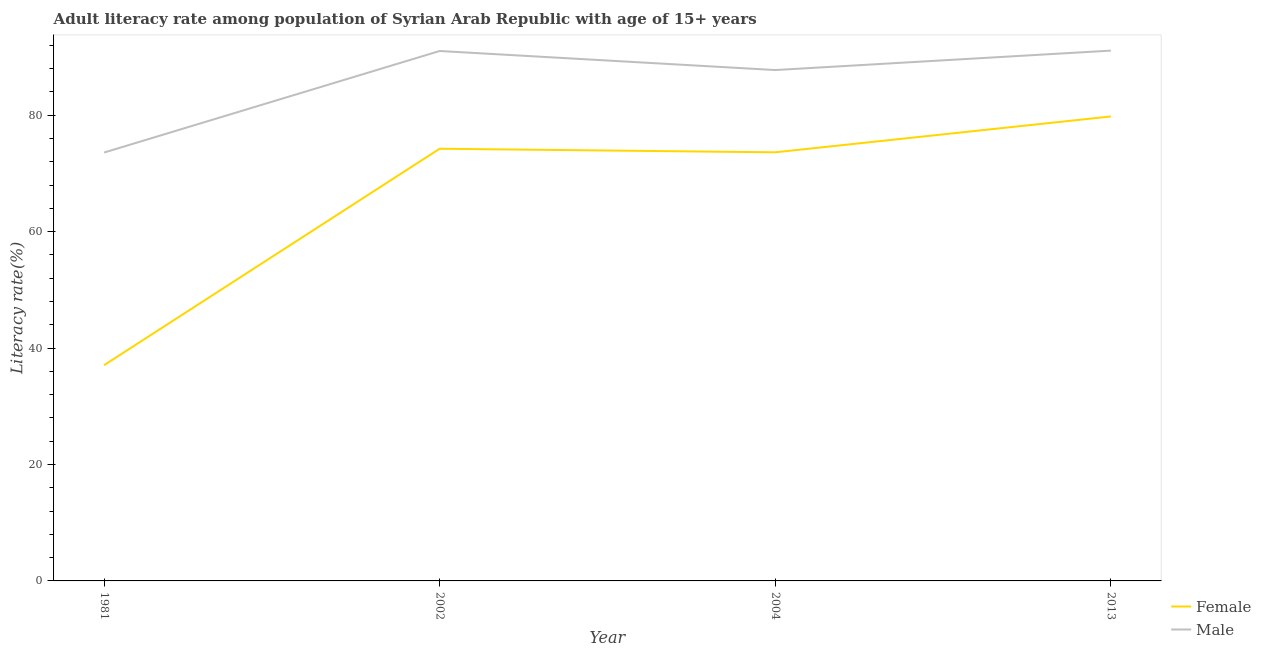Is the number of lines equal to the number of legend labels?
Keep it short and to the point. Yes. What is the male adult literacy rate in 2002?
Keep it short and to the point. 91.03. Across all years, what is the maximum female adult literacy rate?
Give a very brief answer. 79.79. Across all years, what is the minimum male adult literacy rate?
Provide a short and direct response. 73.58. What is the total female adult literacy rate in the graph?
Ensure brevity in your answer.  264.71. What is the difference between the female adult literacy rate in 2004 and that in 2013?
Make the answer very short. -6.16. What is the difference between the female adult literacy rate in 2004 and the male adult literacy rate in 2002?
Offer a terse response. -17.4. What is the average male adult literacy rate per year?
Provide a succinct answer. 85.87. In the year 2002, what is the difference between the male adult literacy rate and female adult literacy rate?
Offer a terse response. 16.79. What is the ratio of the male adult literacy rate in 2004 to that in 2013?
Ensure brevity in your answer.  0.96. Is the female adult literacy rate in 2002 less than that in 2013?
Keep it short and to the point. Yes. What is the difference between the highest and the second highest male adult literacy rate?
Keep it short and to the point. 0.07. What is the difference between the highest and the lowest female adult literacy rate?
Make the answer very short. 42.73. Is the female adult literacy rate strictly less than the male adult literacy rate over the years?
Give a very brief answer. Yes. How many years are there in the graph?
Your answer should be compact. 4. Are the values on the major ticks of Y-axis written in scientific E-notation?
Ensure brevity in your answer.  No. Does the graph contain any zero values?
Make the answer very short. No. Where does the legend appear in the graph?
Make the answer very short. Bottom right. How many legend labels are there?
Your response must be concise. 2. How are the legend labels stacked?
Offer a terse response. Vertical. What is the title of the graph?
Make the answer very short. Adult literacy rate among population of Syrian Arab Republic with age of 15+ years. What is the label or title of the Y-axis?
Make the answer very short. Literacy rate(%). What is the Literacy rate(%) in Female in 1981?
Your answer should be compact. 37.06. What is the Literacy rate(%) of Male in 1981?
Keep it short and to the point. 73.58. What is the Literacy rate(%) in Female in 2002?
Ensure brevity in your answer.  74.24. What is the Literacy rate(%) in Male in 2002?
Ensure brevity in your answer.  91.03. What is the Literacy rate(%) in Female in 2004?
Your answer should be compact. 73.63. What is the Literacy rate(%) of Male in 2004?
Offer a terse response. 87.76. What is the Literacy rate(%) in Female in 2013?
Keep it short and to the point. 79.79. What is the Literacy rate(%) in Male in 2013?
Offer a very short reply. 91.1. Across all years, what is the maximum Literacy rate(%) of Female?
Your answer should be compact. 79.79. Across all years, what is the maximum Literacy rate(%) of Male?
Your answer should be compact. 91.1. Across all years, what is the minimum Literacy rate(%) of Female?
Your answer should be very brief. 37.06. Across all years, what is the minimum Literacy rate(%) in Male?
Your response must be concise. 73.58. What is the total Literacy rate(%) of Female in the graph?
Keep it short and to the point. 264.71. What is the total Literacy rate(%) in Male in the graph?
Ensure brevity in your answer.  343.47. What is the difference between the Literacy rate(%) in Female in 1981 and that in 2002?
Your response must be concise. -37.18. What is the difference between the Literacy rate(%) in Male in 1981 and that in 2002?
Make the answer very short. -17.44. What is the difference between the Literacy rate(%) of Female in 1981 and that in 2004?
Your answer should be very brief. -36.57. What is the difference between the Literacy rate(%) in Male in 1981 and that in 2004?
Offer a very short reply. -14.17. What is the difference between the Literacy rate(%) of Female in 1981 and that in 2013?
Your answer should be very brief. -42.73. What is the difference between the Literacy rate(%) of Male in 1981 and that in 2013?
Offer a terse response. -17.51. What is the difference between the Literacy rate(%) in Female in 2002 and that in 2004?
Provide a succinct answer. 0.61. What is the difference between the Literacy rate(%) in Male in 2002 and that in 2004?
Offer a terse response. 3.27. What is the difference between the Literacy rate(%) of Female in 2002 and that in 2013?
Provide a succinct answer. -5.55. What is the difference between the Literacy rate(%) of Male in 2002 and that in 2013?
Provide a succinct answer. -0.07. What is the difference between the Literacy rate(%) in Female in 2004 and that in 2013?
Ensure brevity in your answer.  -6.16. What is the difference between the Literacy rate(%) in Male in 2004 and that in 2013?
Keep it short and to the point. -3.34. What is the difference between the Literacy rate(%) of Female in 1981 and the Literacy rate(%) of Male in 2002?
Ensure brevity in your answer.  -53.97. What is the difference between the Literacy rate(%) in Female in 1981 and the Literacy rate(%) in Male in 2004?
Give a very brief answer. -50.7. What is the difference between the Literacy rate(%) in Female in 1981 and the Literacy rate(%) in Male in 2013?
Make the answer very short. -54.04. What is the difference between the Literacy rate(%) in Female in 2002 and the Literacy rate(%) in Male in 2004?
Keep it short and to the point. -13.52. What is the difference between the Literacy rate(%) in Female in 2002 and the Literacy rate(%) in Male in 2013?
Your answer should be very brief. -16.86. What is the difference between the Literacy rate(%) in Female in 2004 and the Literacy rate(%) in Male in 2013?
Make the answer very short. -17.47. What is the average Literacy rate(%) in Female per year?
Give a very brief answer. 66.18. What is the average Literacy rate(%) in Male per year?
Your answer should be very brief. 85.87. In the year 1981, what is the difference between the Literacy rate(%) in Female and Literacy rate(%) in Male?
Give a very brief answer. -36.53. In the year 2002, what is the difference between the Literacy rate(%) in Female and Literacy rate(%) in Male?
Ensure brevity in your answer.  -16.79. In the year 2004, what is the difference between the Literacy rate(%) in Female and Literacy rate(%) in Male?
Your answer should be very brief. -14.13. In the year 2013, what is the difference between the Literacy rate(%) of Female and Literacy rate(%) of Male?
Provide a short and direct response. -11.31. What is the ratio of the Literacy rate(%) of Female in 1981 to that in 2002?
Give a very brief answer. 0.5. What is the ratio of the Literacy rate(%) in Male in 1981 to that in 2002?
Your answer should be very brief. 0.81. What is the ratio of the Literacy rate(%) in Female in 1981 to that in 2004?
Offer a very short reply. 0.5. What is the ratio of the Literacy rate(%) in Male in 1981 to that in 2004?
Your answer should be compact. 0.84. What is the ratio of the Literacy rate(%) of Female in 1981 to that in 2013?
Your answer should be compact. 0.46. What is the ratio of the Literacy rate(%) of Male in 1981 to that in 2013?
Offer a very short reply. 0.81. What is the ratio of the Literacy rate(%) in Female in 2002 to that in 2004?
Keep it short and to the point. 1.01. What is the ratio of the Literacy rate(%) of Male in 2002 to that in 2004?
Make the answer very short. 1.04. What is the ratio of the Literacy rate(%) in Female in 2002 to that in 2013?
Offer a very short reply. 0.93. What is the ratio of the Literacy rate(%) of Female in 2004 to that in 2013?
Your answer should be very brief. 0.92. What is the ratio of the Literacy rate(%) in Male in 2004 to that in 2013?
Offer a terse response. 0.96. What is the difference between the highest and the second highest Literacy rate(%) in Female?
Offer a very short reply. 5.55. What is the difference between the highest and the second highest Literacy rate(%) in Male?
Your answer should be compact. 0.07. What is the difference between the highest and the lowest Literacy rate(%) of Female?
Your answer should be very brief. 42.73. What is the difference between the highest and the lowest Literacy rate(%) of Male?
Offer a terse response. 17.51. 